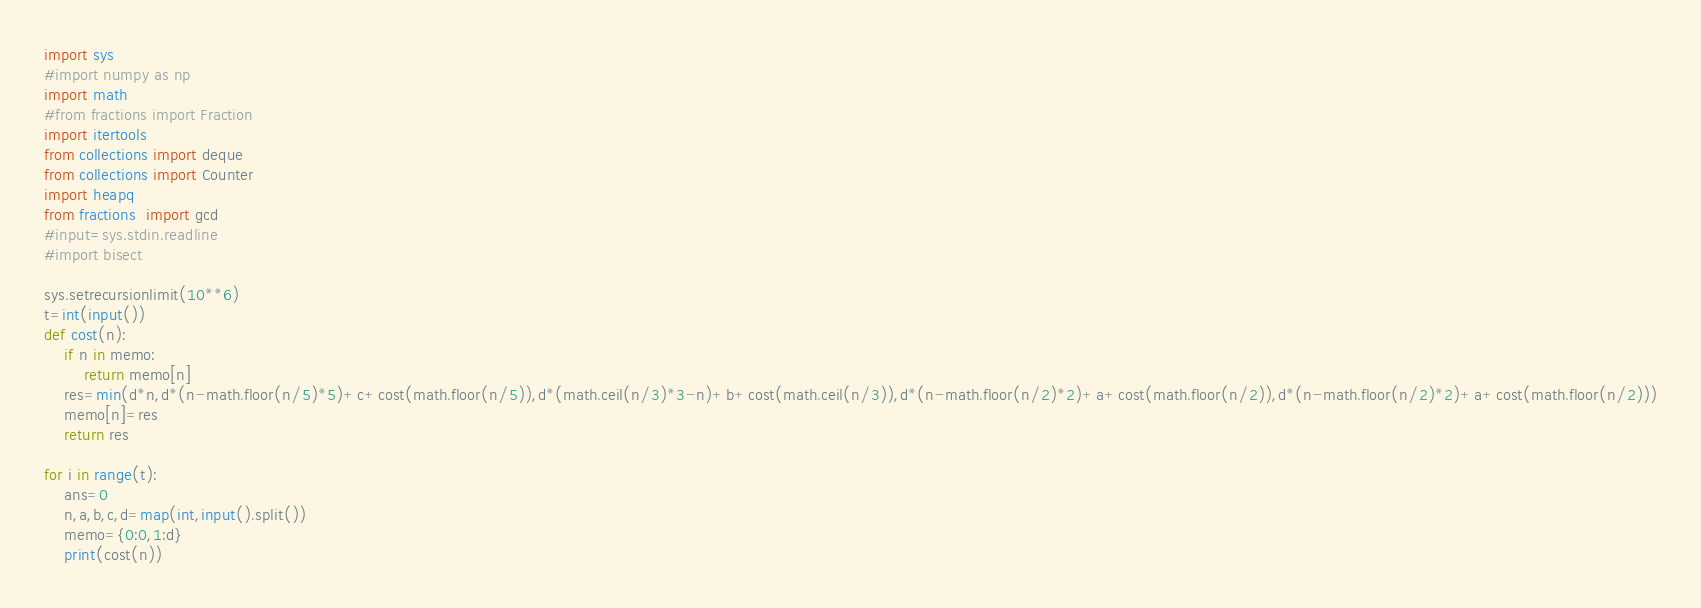<code> <loc_0><loc_0><loc_500><loc_500><_Python_>import sys
#import numpy as np
import math
#from fractions import Fraction
import itertools
from collections import deque
from collections import Counter
import heapq
from fractions  import gcd
#input=sys.stdin.readline
#import bisect

sys.setrecursionlimit(10**6)
t=int(input())
def cost(n):
    if n in memo:
        return memo[n]
    res=min(d*n,d*(n-math.floor(n/5)*5)+c+cost(math.floor(n/5)),d*(math.ceil(n/3)*3-n)+b+cost(math.ceil(n/3)),d*(n-math.floor(n/2)*2)+a+cost(math.floor(n/2)),d*(n-math.floor(n/2)*2)+a+cost(math.floor(n/2)))
    memo[n]=res
    return res

for i in range(t):
    ans=0
    n,a,b,c,d=map(int,input().split())
    memo={0:0,1:d}
    print(cost(n))</code> 